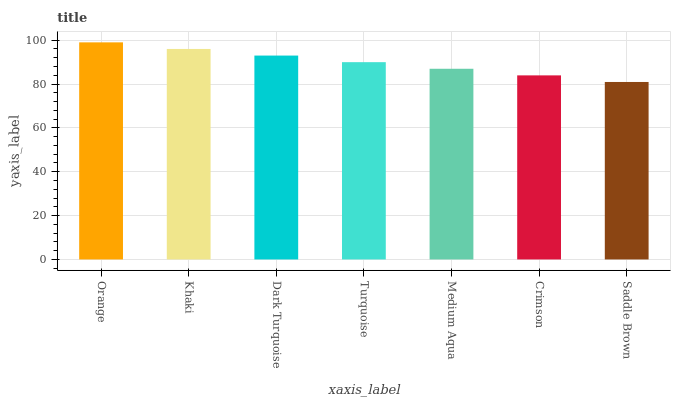Is Saddle Brown the minimum?
Answer yes or no. Yes. Is Orange the maximum?
Answer yes or no. Yes. Is Khaki the minimum?
Answer yes or no. No. Is Khaki the maximum?
Answer yes or no. No. Is Orange greater than Khaki?
Answer yes or no. Yes. Is Khaki less than Orange?
Answer yes or no. Yes. Is Khaki greater than Orange?
Answer yes or no. No. Is Orange less than Khaki?
Answer yes or no. No. Is Turquoise the high median?
Answer yes or no. Yes. Is Turquoise the low median?
Answer yes or no. Yes. Is Orange the high median?
Answer yes or no. No. Is Crimson the low median?
Answer yes or no. No. 